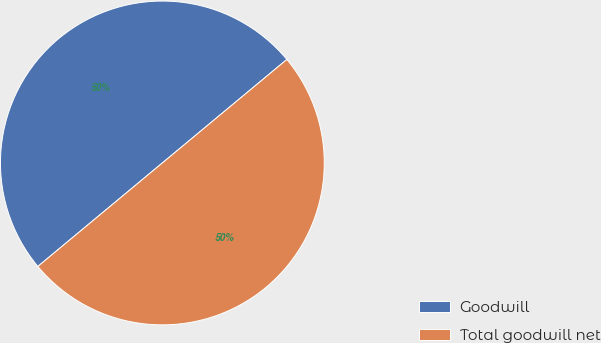<chart> <loc_0><loc_0><loc_500><loc_500><pie_chart><fcel>Goodwill<fcel>Total goodwill net<nl><fcel>50.0%<fcel>50.0%<nl></chart> 